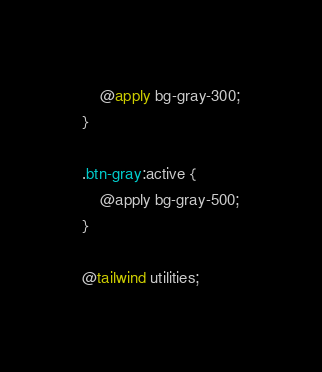Convert code to text. <code><loc_0><loc_0><loc_500><loc_500><_CSS_>    @apply bg-gray-300;
} 

.btn-gray:active {
    @apply bg-gray-500;
}

@tailwind utilities;</code> 